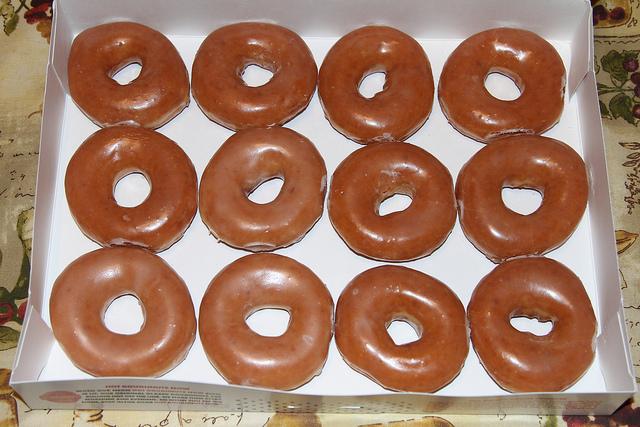Are there and different donuts in the box?
Write a very short answer. No. Are all these donuts the same?
Keep it brief. Yes. What color is the box?
Write a very short answer. White. 